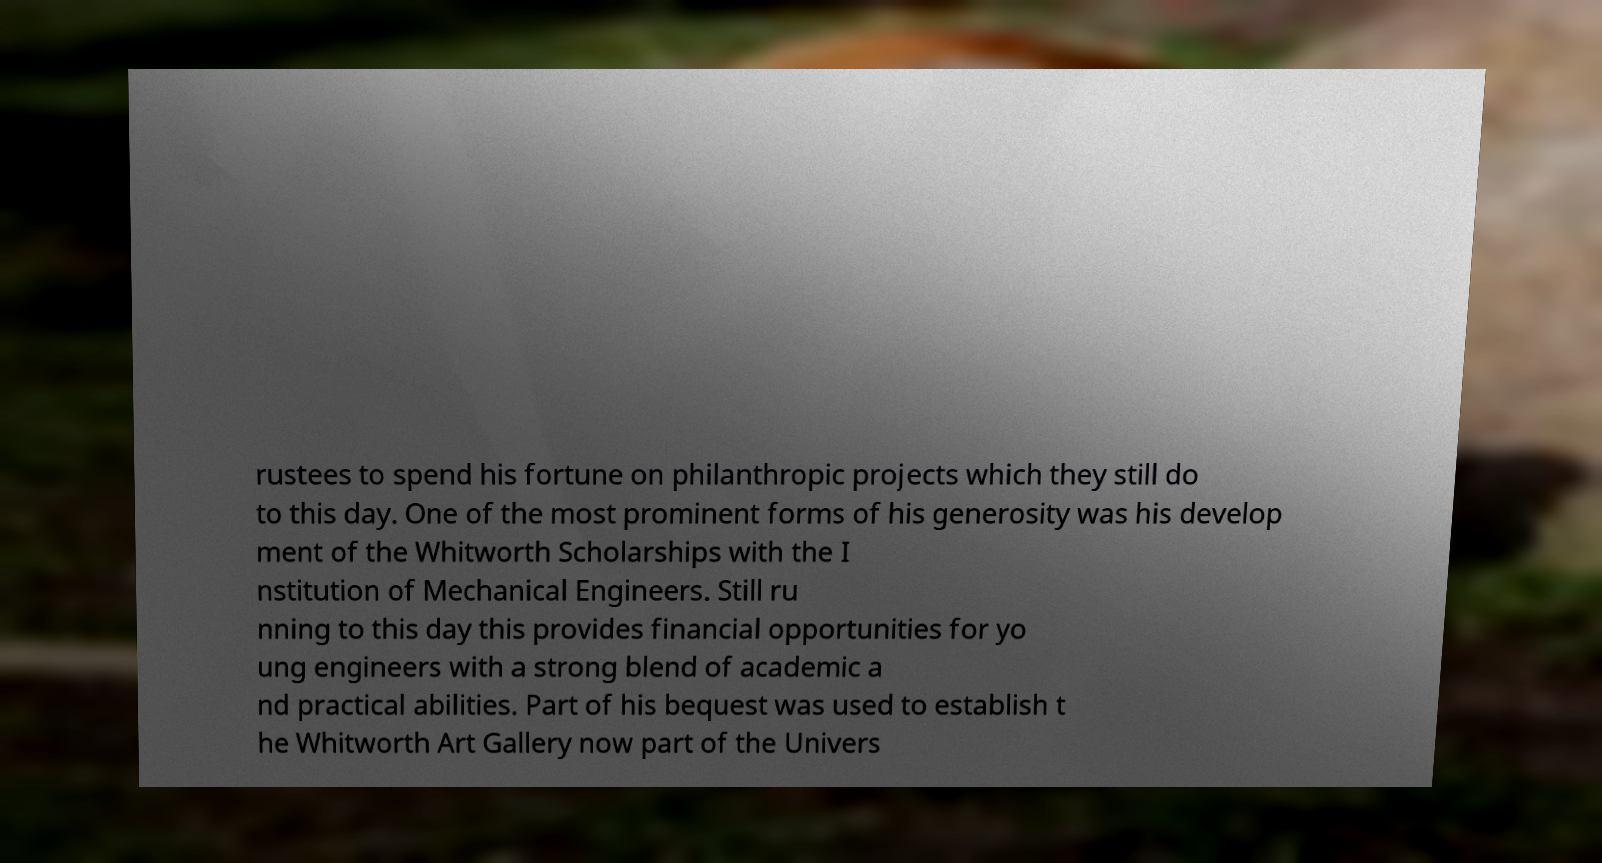Please identify and transcribe the text found in this image. rustees to spend his fortune on philanthropic projects which they still do to this day. One of the most prominent forms of his generosity was his develop ment of the Whitworth Scholarships with the I nstitution of Mechanical Engineers. Still ru nning to this day this provides financial opportunities for yo ung engineers with a strong blend of academic a nd practical abilities. Part of his bequest was used to establish t he Whitworth Art Gallery now part of the Univers 